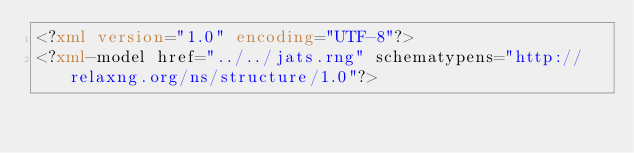<code> <loc_0><loc_0><loc_500><loc_500><_XML_><?xml version="1.0" encoding="UTF-8"?>
<?xml-model href="../../jats.rng" schematypens="http://relaxng.org/ns/structure/1.0"?></code> 